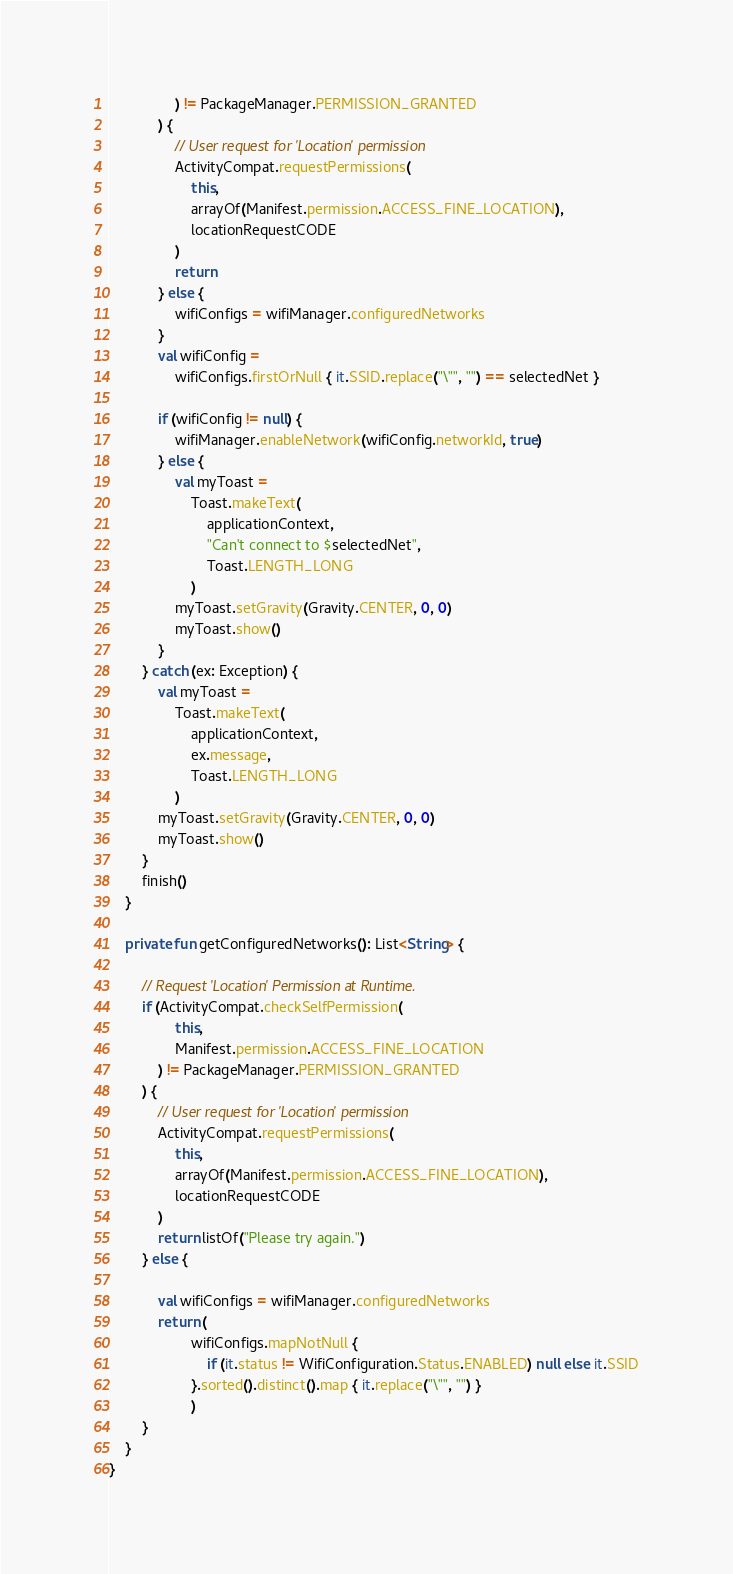Convert code to text. <code><loc_0><loc_0><loc_500><loc_500><_Kotlin_>                ) != PackageManager.PERMISSION_GRANTED
            ) {
                // User request for 'Location' permission
                ActivityCompat.requestPermissions(
                    this,
                    arrayOf(Manifest.permission.ACCESS_FINE_LOCATION),
                    locationRequestCODE
                )
                return
            } else {
                wifiConfigs = wifiManager.configuredNetworks
            }
            val wifiConfig =
                wifiConfigs.firstOrNull { it.SSID.replace("\"", "") == selectedNet }

            if (wifiConfig != null) {
                wifiManager.enableNetwork(wifiConfig.networkId, true)
            } else {
                val myToast =
                    Toast.makeText(
                        applicationContext,
                        "Can't connect to $selectedNet",
                        Toast.LENGTH_LONG
                    )
                myToast.setGravity(Gravity.CENTER, 0, 0)
                myToast.show()
            }
        } catch (ex: Exception) {
            val myToast =
                Toast.makeText(
                    applicationContext,
                    ex.message,
                    Toast.LENGTH_LONG
                )
            myToast.setGravity(Gravity.CENTER, 0, 0)
            myToast.show()
        }
        finish()
    }

    private fun getConfiguredNetworks(): List<String> {

        // Request 'Location' Permission at Runtime.
        if (ActivityCompat.checkSelfPermission(
                this,
                Manifest.permission.ACCESS_FINE_LOCATION
            ) != PackageManager.PERMISSION_GRANTED
        ) {
            // User request for 'Location' permission
            ActivityCompat.requestPermissions(
                this,
                arrayOf(Manifest.permission.ACCESS_FINE_LOCATION),
                locationRequestCODE
            )
            return listOf("Please try again.")
        } else {

            val wifiConfigs = wifiManager.configuredNetworks
            return (
                    wifiConfigs.mapNotNull {
                        if (it.status != WifiConfiguration.Status.ENABLED) null else it.SSID
                    }.sorted().distinct().map { it.replace("\"", "") }
                    )
        }
    }
}</code> 